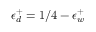Convert formula to latex. <formula><loc_0><loc_0><loc_500><loc_500>\epsilon _ { d } ^ { + } = 1 / 4 - \epsilon _ { w } ^ { + }</formula> 